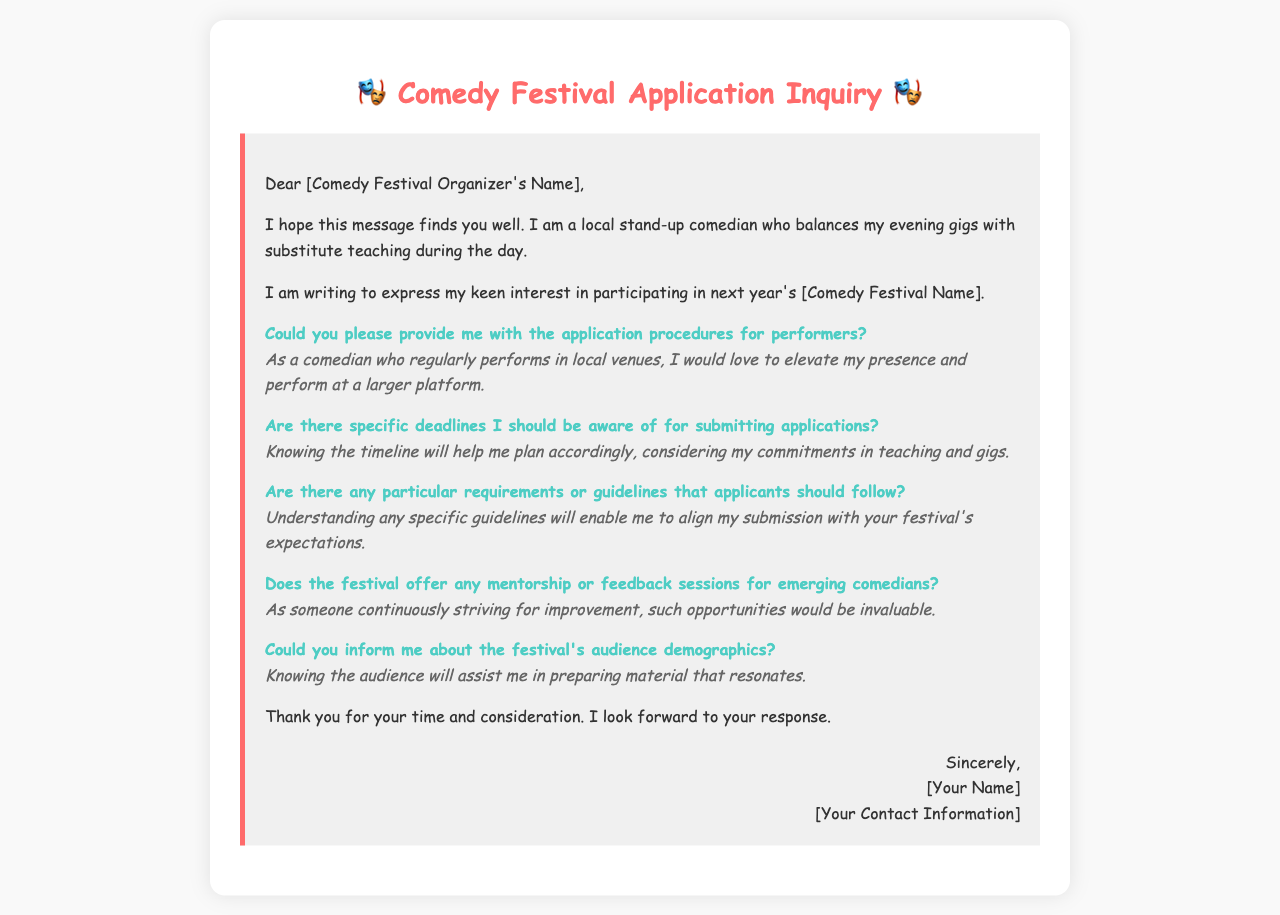What is the recipient's title? The title is indicated in the salutation of the letter, which is to a "Comedy Festival Organizer."
Answer: Comedy Festival Organizer What is the purpose of the letter? The purpose is clearly stated in the first paragraph, which expresses interest in participating in the festival.
Answer: Participation inquiry What type of performer is the sender? The sender identifies themselves as a "local stand-up comedian" in the opening paragraph.
Answer: Stand-up comedian What specific festival is being inquired about? The sender asks about "next year's [Comedy Festival Name]," indicating an inquiry about a specific unnamed festival.
Answer: [Comedy Festival Name] What does the sender want to know about application procedures? The sender specifically asks for the application procedures for performers, showing their interest in the details.
Answer: Application procedures What kind of assistance does the sender seek from the festival? The sender inquires about mentorship or feedback sessions, indicating a desire for growth and support in comedy.
Answer: Mentorship or feedback sessions What does the sender hope to understand regarding the audience? The sender asks about the audience demographics, indicating a need to connect with the festival's attendees.
Answer: Audience demographics What is the sender currently balancing along with comedy? The sender mentions balancing substitute teaching along with their evening gigs as a comedian.
Answer: Substitute teaching What is one reason the sender wants timeline information? The sender expresses that knowing the timeline will help them plan considering their commitments.
Answer: Planning accordingly 